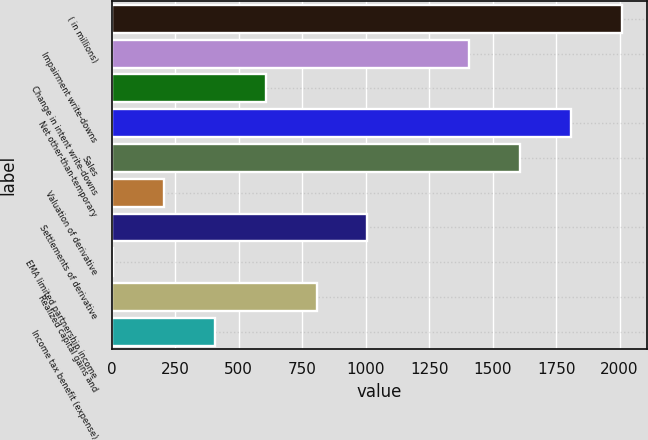Convert chart to OTSL. <chart><loc_0><loc_0><loc_500><loc_500><bar_chart><fcel>( in millions)<fcel>Impairment write-downs<fcel>Change in intent write-downs<fcel>Net other-than-temporary<fcel>Sales<fcel>Valuation of derivative<fcel>Settlements of derivative<fcel>EMA limited partnership income<fcel>Realized capital gains and<fcel>Income tax benefit (expense)<nl><fcel>2009<fcel>1407.8<fcel>606.2<fcel>1808.6<fcel>1608.2<fcel>205.4<fcel>1007<fcel>5<fcel>806.6<fcel>405.8<nl></chart> 